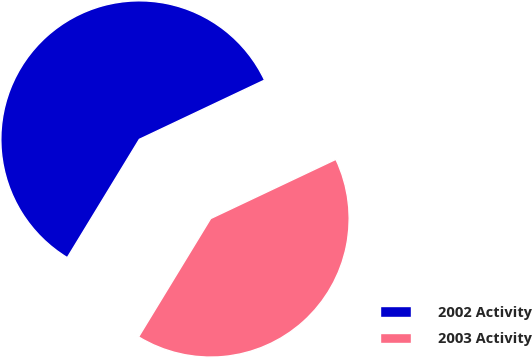Convert chart. <chart><loc_0><loc_0><loc_500><loc_500><pie_chart><fcel>2002 Activity<fcel>2003 Activity<nl><fcel>59.26%<fcel>40.74%<nl></chart> 